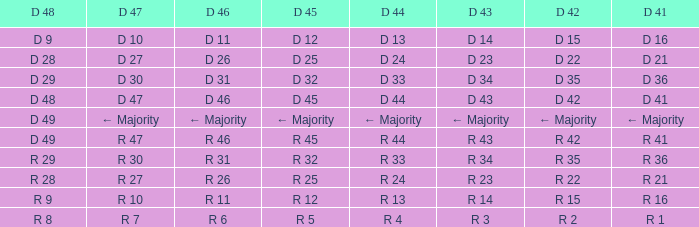Parse the full table. {'header': ['D 48', 'D 47', 'D 46', 'D 45', 'D 44', 'D 43', 'D 42', 'D 41'], 'rows': [['D 9', 'D 10', 'D 11', 'D 12', 'D 13', 'D 14', 'D 15', 'D 16'], ['D 28', 'D 27', 'D 26', 'D 25', 'D 24', 'D 23', 'D 22', 'D 21'], ['D 29', 'D 30', 'D 31', 'D 32', 'D 33', 'D 34', 'D 35', 'D 36'], ['D 48', 'D 47', 'D 46', 'D 45', 'D 44', 'D 43', 'D 42', 'D 41'], ['D 49', '← Majority', '← Majority', '← Majority', '← Majority', '← Majority', '← Majority', '← Majority'], ['D 49', 'R 47', 'R 46', 'R 45', 'R 44', 'R 43', 'R 42', 'R 41'], ['R 29', 'R 30', 'R 31', 'R 32', 'R 33', 'R 34', 'R 35', 'R 36'], ['R 28', 'R 27', 'R 26', 'R 25', 'R 24', 'R 23', 'R 22', 'R 21'], ['R 9', 'R 10', 'R 11', 'R 12', 'R 13', 'R 14', 'R 15', 'R 16'], ['R 8', 'R 7', 'R 6', 'R 5', 'R 4', 'R 3', 'R 2', 'R 1']]} When the d 44 has a d 46 with d 31, what is it referred to as? D 33. 